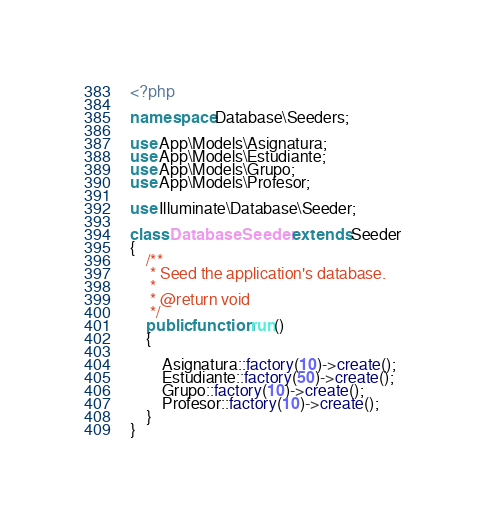Convert code to text. <code><loc_0><loc_0><loc_500><loc_500><_PHP_><?php

namespace Database\Seeders;

use App\Models\Asignatura;
use App\Models\Estudiante;
use App\Models\Grupo;
use App\Models\Profesor;

use Illuminate\Database\Seeder;

class DatabaseSeeder extends Seeder
{
    /**
     * Seed the application's database.
     *
     * @return void
     */
    public function run()
    {

        Asignatura::factory(10)->create();
        Estudiante::factory(50)->create();
        Grupo::factory(10)->create();
        Profesor::factory(10)->create();
    }
}
</code> 